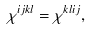<formula> <loc_0><loc_0><loc_500><loc_500>\chi ^ { i j k l } = \chi ^ { k l i j } ,</formula> 